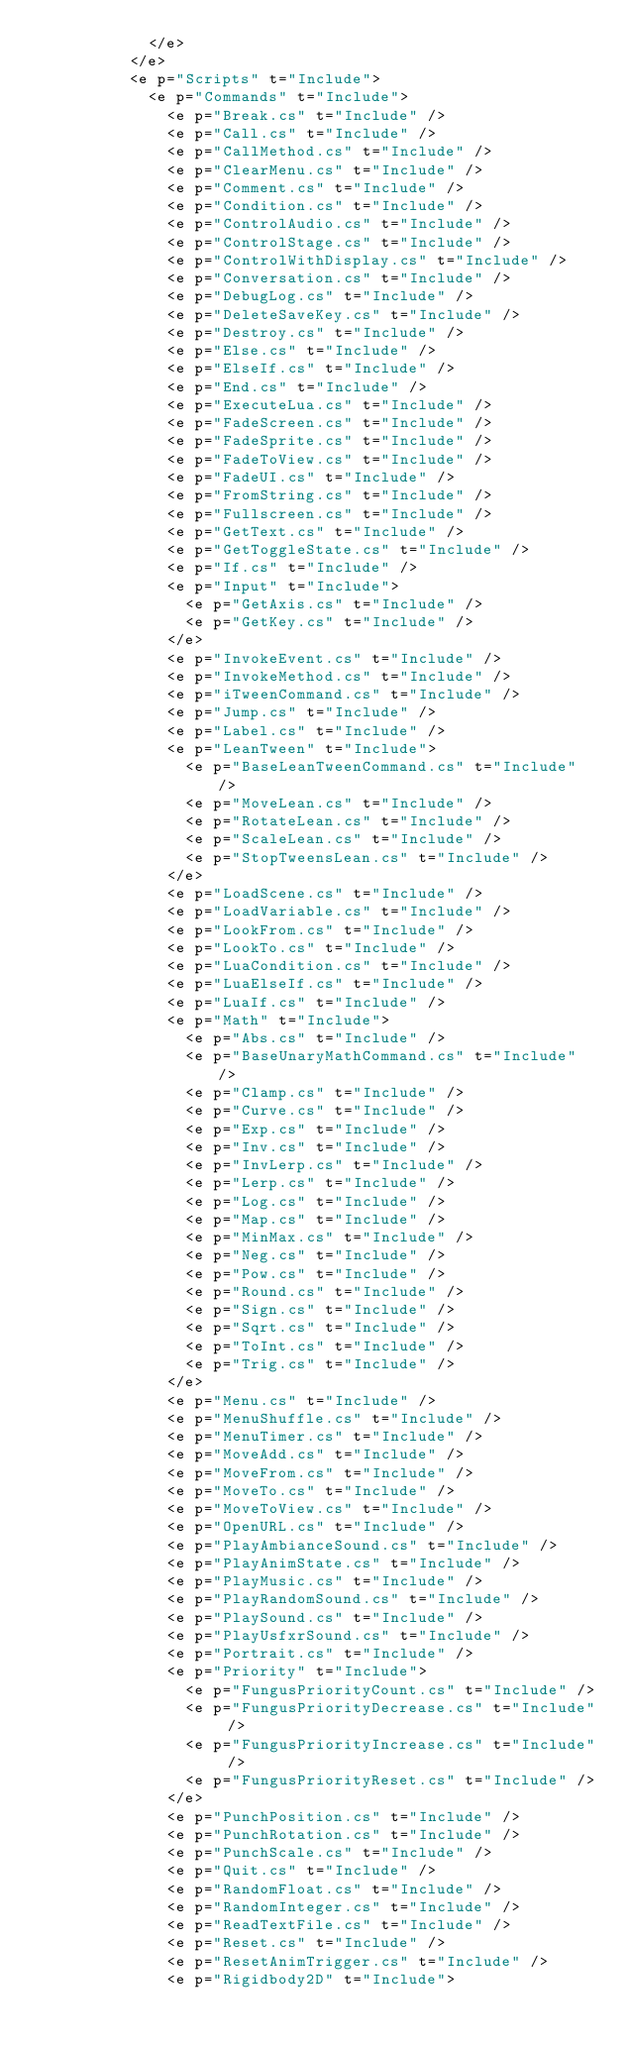<code> <loc_0><loc_0><loc_500><loc_500><_XML_>            </e>
          </e>
          <e p="Scripts" t="Include">
            <e p="Commands" t="Include">
              <e p="Break.cs" t="Include" />
              <e p="Call.cs" t="Include" />
              <e p="CallMethod.cs" t="Include" />
              <e p="ClearMenu.cs" t="Include" />
              <e p="Comment.cs" t="Include" />
              <e p="Condition.cs" t="Include" />
              <e p="ControlAudio.cs" t="Include" />
              <e p="ControlStage.cs" t="Include" />
              <e p="ControlWithDisplay.cs" t="Include" />
              <e p="Conversation.cs" t="Include" />
              <e p="DebugLog.cs" t="Include" />
              <e p="DeleteSaveKey.cs" t="Include" />
              <e p="Destroy.cs" t="Include" />
              <e p="Else.cs" t="Include" />
              <e p="ElseIf.cs" t="Include" />
              <e p="End.cs" t="Include" />
              <e p="ExecuteLua.cs" t="Include" />
              <e p="FadeScreen.cs" t="Include" />
              <e p="FadeSprite.cs" t="Include" />
              <e p="FadeToView.cs" t="Include" />
              <e p="FadeUI.cs" t="Include" />
              <e p="FromString.cs" t="Include" />
              <e p="Fullscreen.cs" t="Include" />
              <e p="GetText.cs" t="Include" />
              <e p="GetToggleState.cs" t="Include" />
              <e p="If.cs" t="Include" />
              <e p="Input" t="Include">
                <e p="GetAxis.cs" t="Include" />
                <e p="GetKey.cs" t="Include" />
              </e>
              <e p="InvokeEvent.cs" t="Include" />
              <e p="InvokeMethod.cs" t="Include" />
              <e p="iTweenCommand.cs" t="Include" />
              <e p="Jump.cs" t="Include" />
              <e p="Label.cs" t="Include" />
              <e p="LeanTween" t="Include">
                <e p="BaseLeanTweenCommand.cs" t="Include" />
                <e p="MoveLean.cs" t="Include" />
                <e p="RotateLean.cs" t="Include" />
                <e p="ScaleLean.cs" t="Include" />
                <e p="StopTweensLean.cs" t="Include" />
              </e>
              <e p="LoadScene.cs" t="Include" />
              <e p="LoadVariable.cs" t="Include" />
              <e p="LookFrom.cs" t="Include" />
              <e p="LookTo.cs" t="Include" />
              <e p="LuaCondition.cs" t="Include" />
              <e p="LuaElseIf.cs" t="Include" />
              <e p="LuaIf.cs" t="Include" />
              <e p="Math" t="Include">
                <e p="Abs.cs" t="Include" />
                <e p="BaseUnaryMathCommand.cs" t="Include" />
                <e p="Clamp.cs" t="Include" />
                <e p="Curve.cs" t="Include" />
                <e p="Exp.cs" t="Include" />
                <e p="Inv.cs" t="Include" />
                <e p="InvLerp.cs" t="Include" />
                <e p="Lerp.cs" t="Include" />
                <e p="Log.cs" t="Include" />
                <e p="Map.cs" t="Include" />
                <e p="MinMax.cs" t="Include" />
                <e p="Neg.cs" t="Include" />
                <e p="Pow.cs" t="Include" />
                <e p="Round.cs" t="Include" />
                <e p="Sign.cs" t="Include" />
                <e p="Sqrt.cs" t="Include" />
                <e p="ToInt.cs" t="Include" />
                <e p="Trig.cs" t="Include" />
              </e>
              <e p="Menu.cs" t="Include" />
              <e p="MenuShuffle.cs" t="Include" />
              <e p="MenuTimer.cs" t="Include" />
              <e p="MoveAdd.cs" t="Include" />
              <e p="MoveFrom.cs" t="Include" />
              <e p="MoveTo.cs" t="Include" />
              <e p="MoveToView.cs" t="Include" />
              <e p="OpenURL.cs" t="Include" />
              <e p="PlayAmbianceSound.cs" t="Include" />
              <e p="PlayAnimState.cs" t="Include" />
              <e p="PlayMusic.cs" t="Include" />
              <e p="PlayRandomSound.cs" t="Include" />
              <e p="PlaySound.cs" t="Include" />
              <e p="PlayUsfxrSound.cs" t="Include" />
              <e p="Portrait.cs" t="Include" />
              <e p="Priority" t="Include">
                <e p="FungusPriorityCount.cs" t="Include" />
                <e p="FungusPriorityDecrease.cs" t="Include" />
                <e p="FungusPriorityIncrease.cs" t="Include" />
                <e p="FungusPriorityReset.cs" t="Include" />
              </e>
              <e p="PunchPosition.cs" t="Include" />
              <e p="PunchRotation.cs" t="Include" />
              <e p="PunchScale.cs" t="Include" />
              <e p="Quit.cs" t="Include" />
              <e p="RandomFloat.cs" t="Include" />
              <e p="RandomInteger.cs" t="Include" />
              <e p="ReadTextFile.cs" t="Include" />
              <e p="Reset.cs" t="Include" />
              <e p="ResetAnimTrigger.cs" t="Include" />
              <e p="Rigidbody2D" t="Include"></code> 